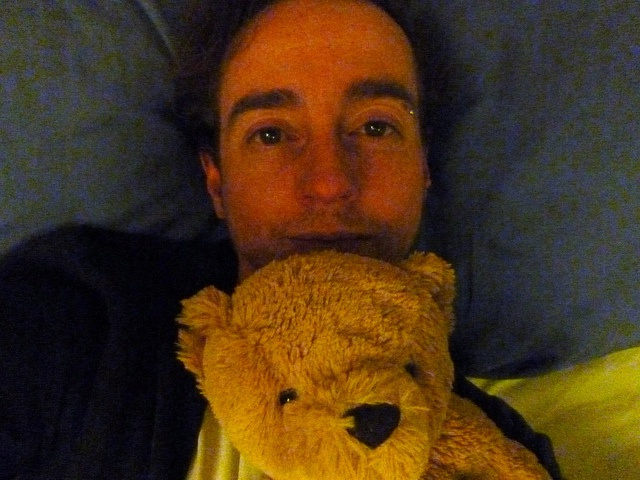Describe the objects in this image and their specific colors. I can see bed in black and darkgreen tones, people in black, maroon, and brown tones, and teddy bear in black, olive, and maroon tones in this image. 